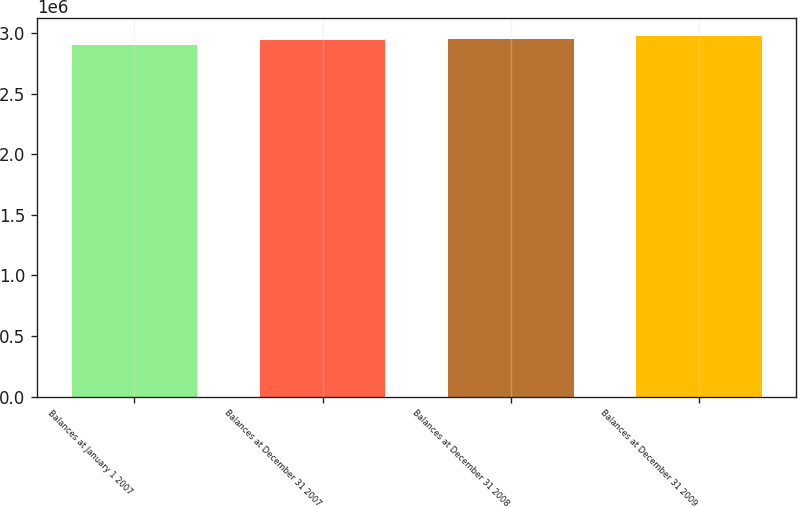<chart> <loc_0><loc_0><loc_500><loc_500><bar_chart><fcel>Balances at January 1 2007<fcel>Balances at December 31 2007<fcel>Balances at December 31 2008<fcel>Balances at December 31 2009<nl><fcel>2.90404e+06<fcel>2.94294e+06<fcel>2.95254e+06<fcel>2.9735e+06<nl></chart> 